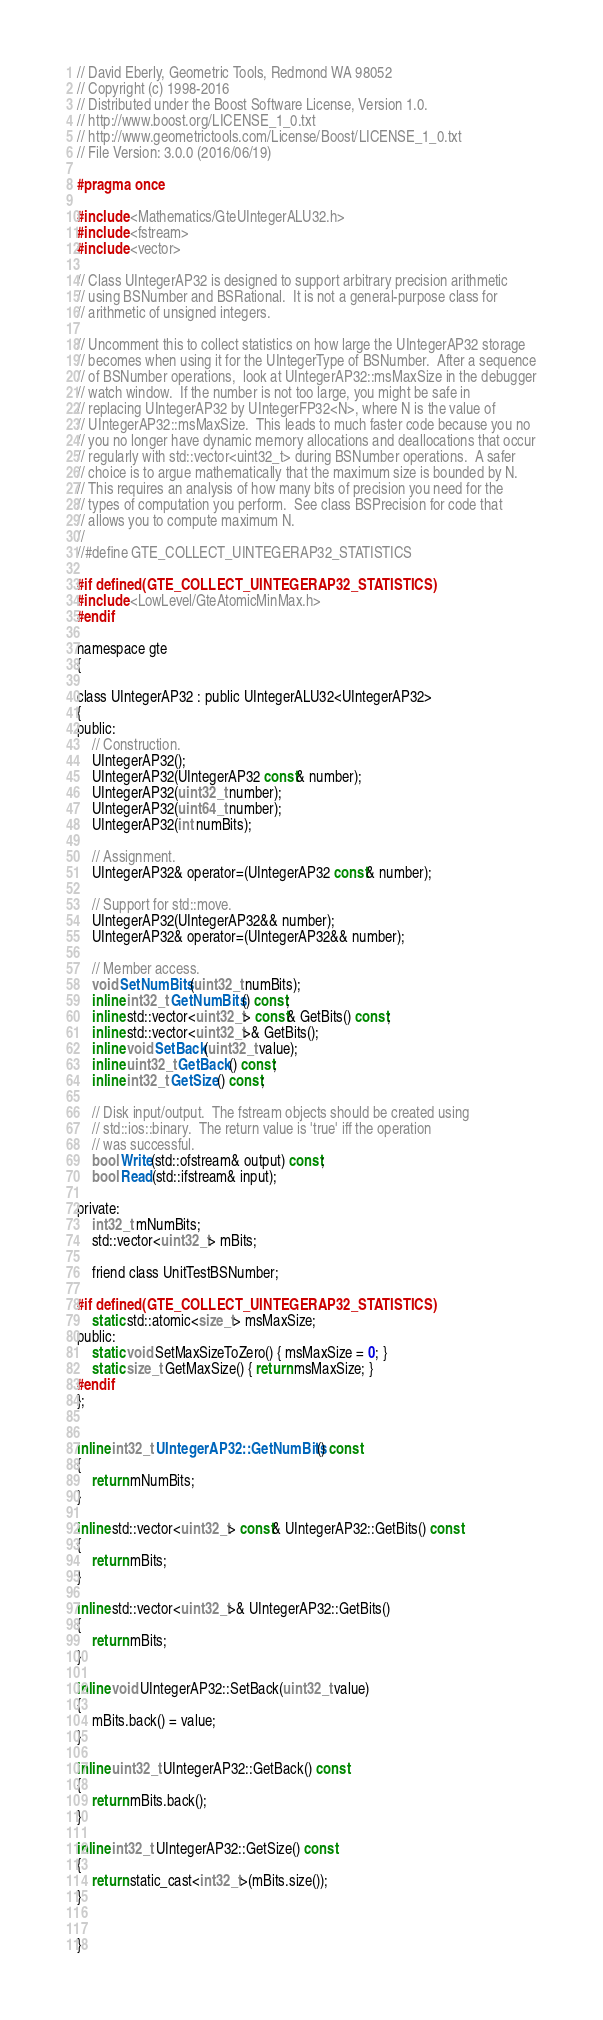<code> <loc_0><loc_0><loc_500><loc_500><_C_>// David Eberly, Geometric Tools, Redmond WA 98052
// Copyright (c) 1998-2016
// Distributed under the Boost Software License, Version 1.0.
// http://www.boost.org/LICENSE_1_0.txt
// http://www.geometrictools.com/License/Boost/LICENSE_1_0.txt
// File Version: 3.0.0 (2016/06/19)

#pragma once

#include <Mathematics/GteUIntegerALU32.h>
#include <fstream>
#include <vector>

// Class UIntegerAP32 is designed to support arbitrary precision arithmetic
// using BSNumber and BSRational.  It is not a general-purpose class for
// arithmetic of unsigned integers.

// Uncomment this to collect statistics on how large the UIntegerAP32 storage
// becomes when using it for the UIntegerType of BSNumber.  After a sequence
// of BSNumber operations,  look at UIntegerAP32::msMaxSize in the debugger
// watch window.  If the number is not too large, you might be safe in
// replacing UIntegerAP32 by UIntegerFP32<N>, where N is the value of
// UIntegerAP32::msMaxSize.  This leads to much faster code because you no
// you no longer have dynamic memory allocations and deallocations that occur
// regularly with std::vector<uint32_t> during BSNumber operations.  A safer
// choice is to argue mathematically that the maximum size is bounded by N.
// This requires an analysis of how many bits of precision you need for the
// types of computation you perform.  See class BSPrecision for code that
// allows you to compute maximum N.
//
//#define GTE_COLLECT_UINTEGERAP32_STATISTICS

#if defined(GTE_COLLECT_UINTEGERAP32_STATISTICS)
#include <LowLevel/GteAtomicMinMax.h>
#endif

namespace gte
{

class UIntegerAP32 : public UIntegerALU32<UIntegerAP32>
{
public:
    // Construction.
    UIntegerAP32();
    UIntegerAP32(UIntegerAP32 const& number);
    UIntegerAP32(uint32_t number);
    UIntegerAP32(uint64_t number);
    UIntegerAP32(int numBits);

    // Assignment.
    UIntegerAP32& operator=(UIntegerAP32 const& number);

    // Support for std::move.
    UIntegerAP32(UIntegerAP32&& number);
    UIntegerAP32& operator=(UIntegerAP32&& number);

    // Member access.
    void SetNumBits(uint32_t numBits);
    inline int32_t GetNumBits() const;
    inline std::vector<uint32_t> const& GetBits() const;
    inline std::vector<uint32_t>& GetBits();
    inline void SetBack(uint32_t value);
    inline uint32_t GetBack() const;
    inline int32_t GetSize() const;

    // Disk input/output.  The fstream objects should be created using
    // std::ios::binary.  The return value is 'true' iff the operation
    // was successful.
    bool Write(std::ofstream& output) const;
    bool Read(std::ifstream& input);

private:
    int32_t mNumBits;
    std::vector<uint32_t> mBits;

    friend class UnitTestBSNumber;

#if defined(GTE_COLLECT_UINTEGERAP32_STATISTICS)
    static std::atomic<size_t> msMaxSize;
public:
    static void SetMaxSizeToZero() { msMaxSize = 0; }
    static size_t GetMaxSize() { return msMaxSize; }
#endif
};


inline int32_t UIntegerAP32::GetNumBits() const
{
    return mNumBits;
}

inline std::vector<uint32_t> const& UIntegerAP32::GetBits() const
{
    return mBits;
}

inline std::vector<uint32_t>& UIntegerAP32::GetBits()
{
    return mBits;
}

inline void UIntegerAP32::SetBack(uint32_t value)
{
    mBits.back() = value;
}

inline uint32_t UIntegerAP32::GetBack() const
{
    return mBits.back();
}

inline int32_t UIntegerAP32::GetSize() const
{
    return static_cast<int32_t>(mBits.size());
}


}
</code> 